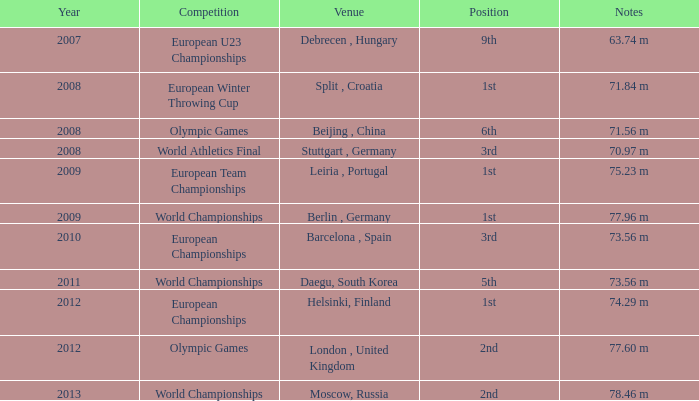After 2012, where was the event held? Moscow, Russia. 